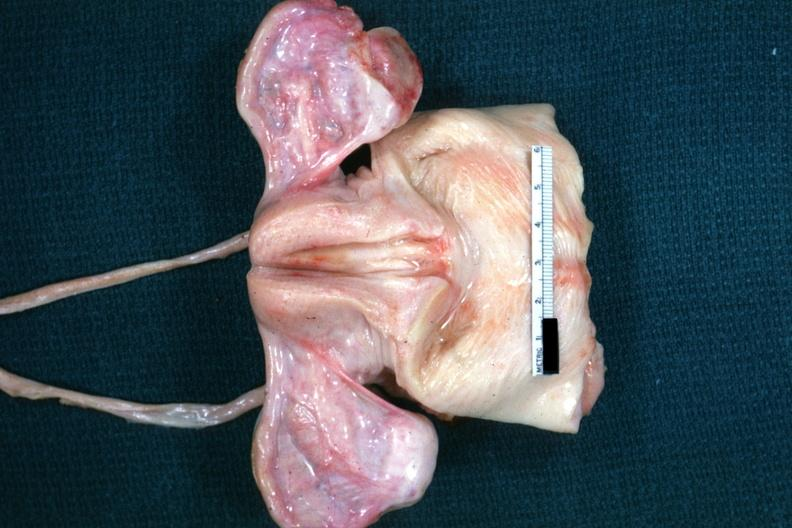how are truly normal ovaries non functional in this case of sella but externally i can see nothing?
Answer the question using a single word or phrase. Vacant 